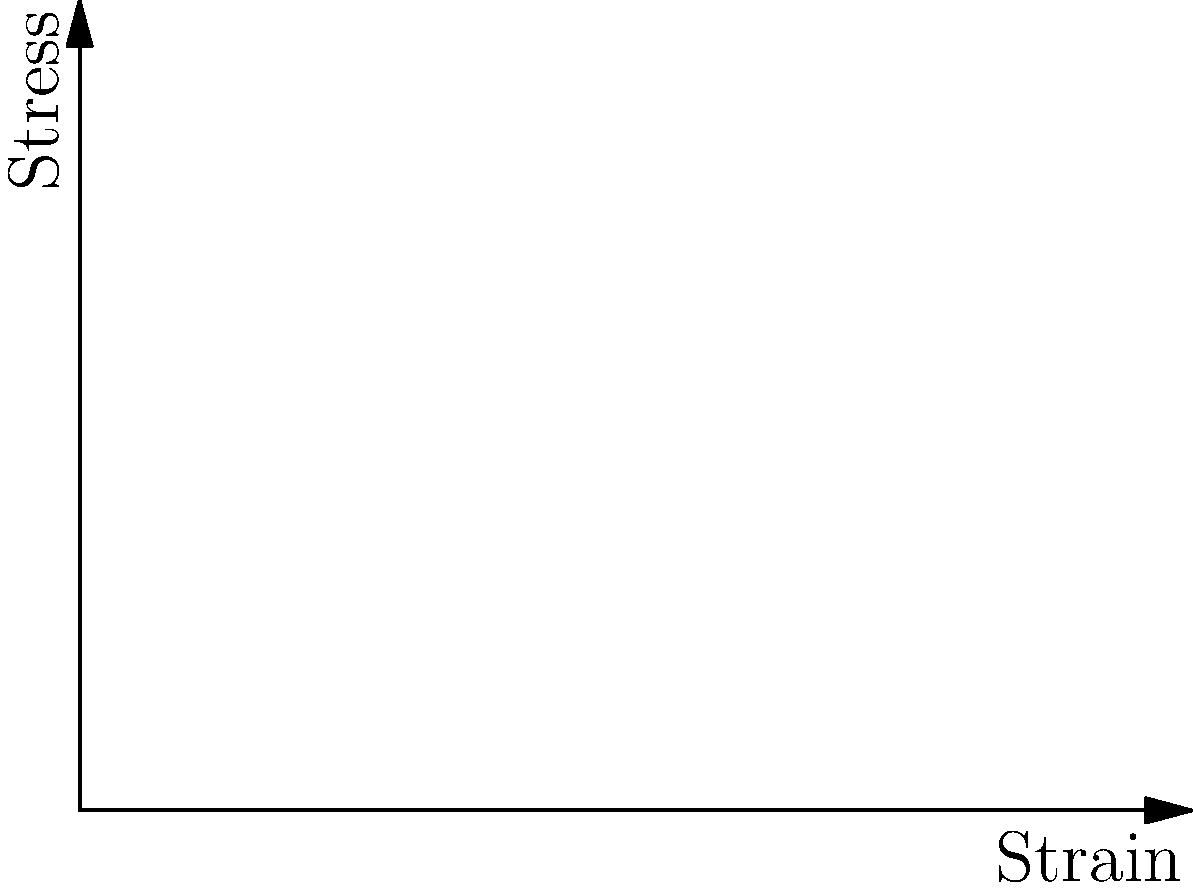Based on the stress-strain curves shown in the graph for materials A, B, and C, which material would be most suitable for use in an aeromodel component that requires high stiffness and minimal deformation under load? To determine the most suitable material for an aeromodel component requiring high stiffness and minimal deformation, we need to analyze the stress-strain curves:

1. Material A (blue line): Shows a linear relationship between stress and strain. This indicates elastic behavior and constant stiffness (Young's modulus).

2. Material B (red line): Displays a parabolic curve, suggesting non-linear elastic behavior. The slope increases with strain, indicating increasing stiffness.

3. Material C (green line): Exhibits a cubic relationship, with a very low initial slope that increases rapidly at higher strains.

For high stiffness, we want a material with a steep slope in the stress-strain curve, as this represents a high Young's modulus ($$E = \frac{\text{stress}}{\text{strain}}$$).

For minimal deformation under load, we need a material that experiences less strain for a given stress.

Comparing the three materials:
- Material A has the steepest initial slope and maintains it throughout.
- Material B starts with a lower slope but increases with strain.
- Material C has the lowest initial slope, only becoming steeper at higher strains.

Therefore, Material A (blue line) would be the most suitable for the aeromodel component, as it offers the highest and most consistent stiffness, resulting in minimal deformation under load.
Answer: Material A 